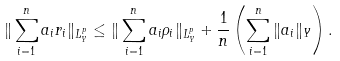<formula> <loc_0><loc_0><loc_500><loc_500>\| \sum _ { i = 1 } ^ { n } a _ { i } r _ { i } \| _ { L ^ { p } _ { Y } } \leq \| \sum _ { i = 1 } ^ { n } a _ { i } \rho _ { i } \| _ { L ^ { p } _ { Y } } + \frac { 1 } { n } \left ( \sum _ { i = 1 } ^ { n } \| a _ { i } \| _ { Y } \right ) .</formula> 